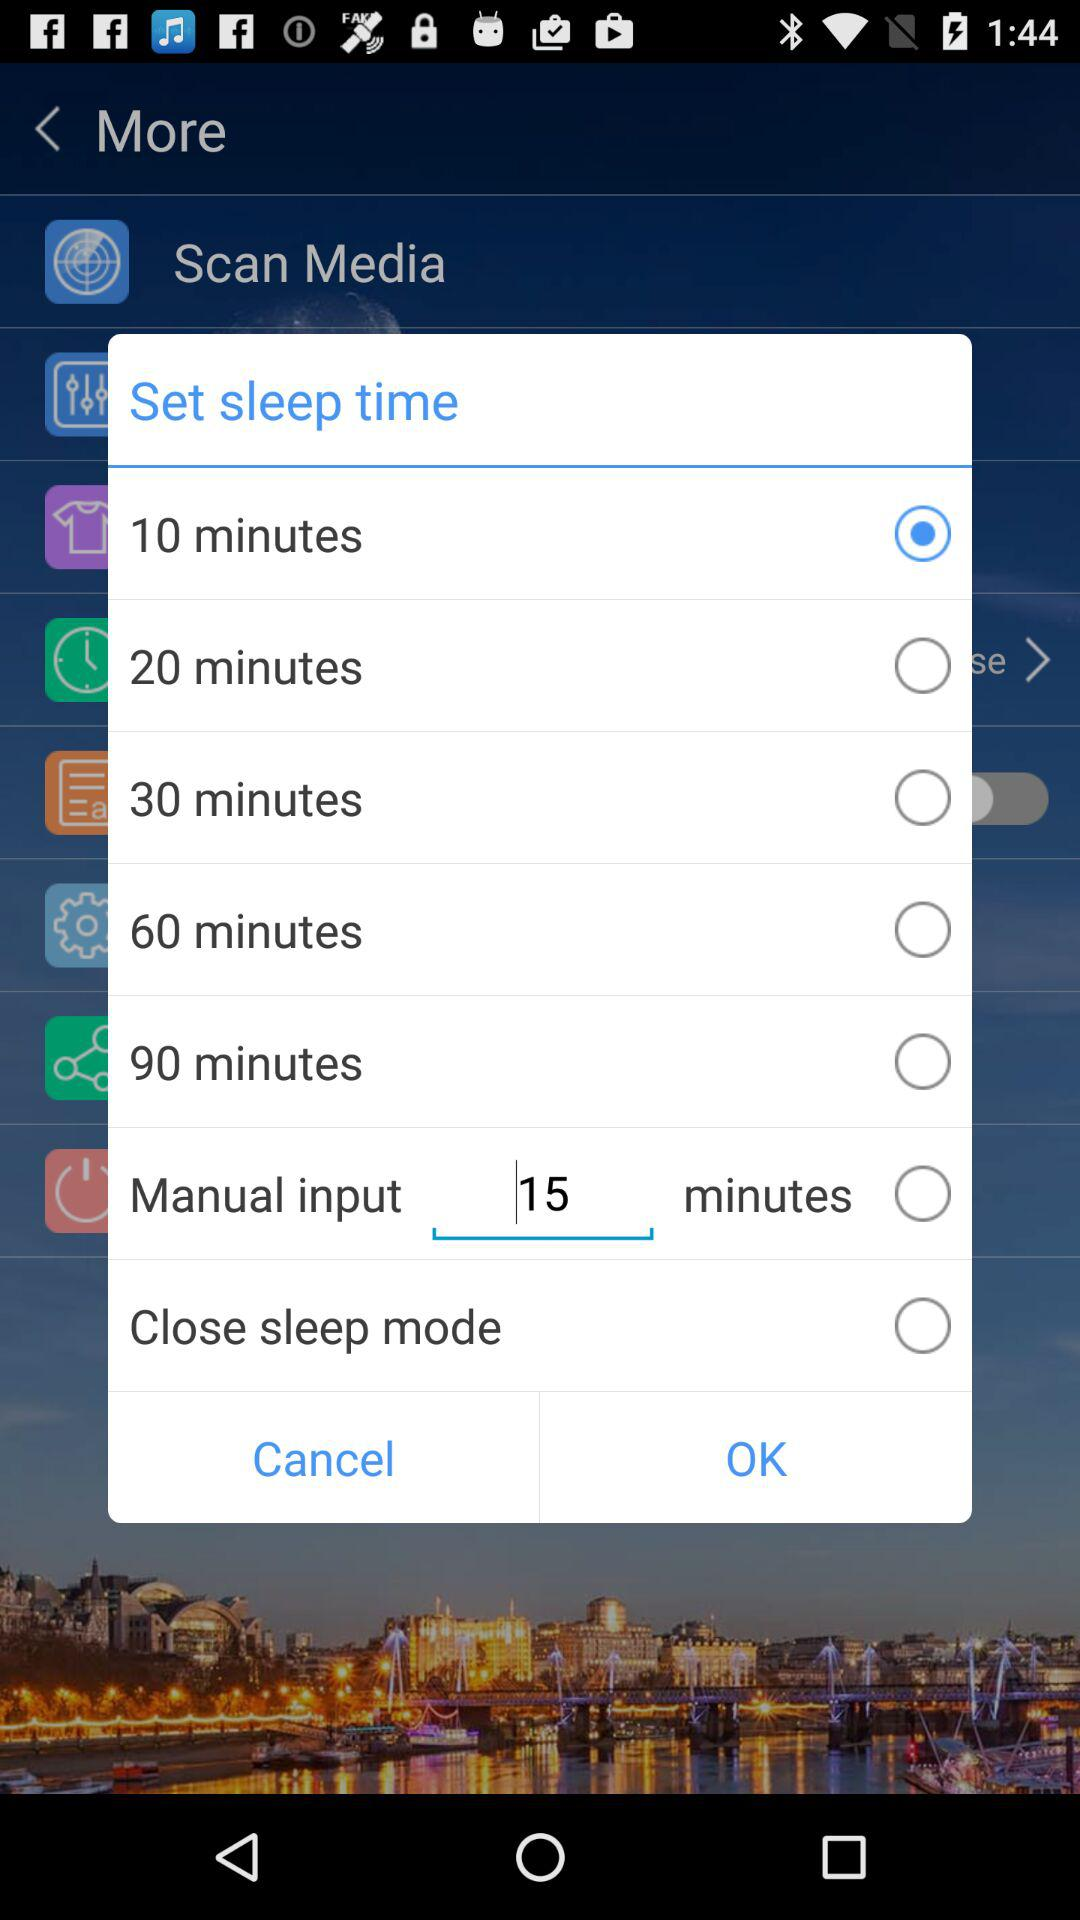What is the manual input time? The manual input time is 15 minutes. 